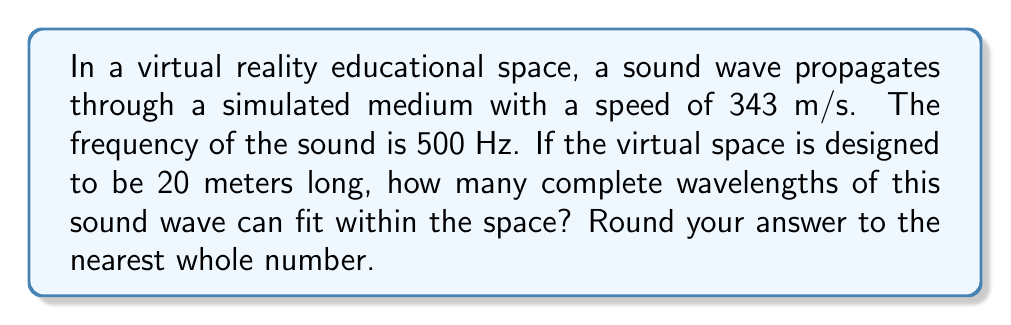Solve this math problem. To solve this problem, we'll follow these steps:

1. Calculate the wavelength of the sound wave:
   The wavelength $\lambda$ is related to the speed $v$ and frequency $f$ by the equation:
   $$v = f\lambda$$
   Rearranging this equation, we get:
   $$\lambda = \frac{v}{f}$$
   
   Substituting the given values:
   $$\lambda = \frac{343 \text{ m/s}}{500 \text{ Hz}} = 0.686 \text{ m}$$

2. Determine how many wavelengths fit in the given space:
   The number of wavelengths $n$ that can fit in a space of length $L$ is given by:
   $$n = \frac{L}{\lambda}$$
   
   Substituting the values:
   $$n = \frac{20 \text{ m}}{0.686 \text{ m}} \approx 29.15$$

3. Round to the nearest whole number:
   Since we can't have a fractional number of complete wavelengths, we round 29.15 to 29.

This result means that 29 complete wavelengths of the 500 Hz sound wave can fit within the 20-meter virtual space.
Answer: 29 